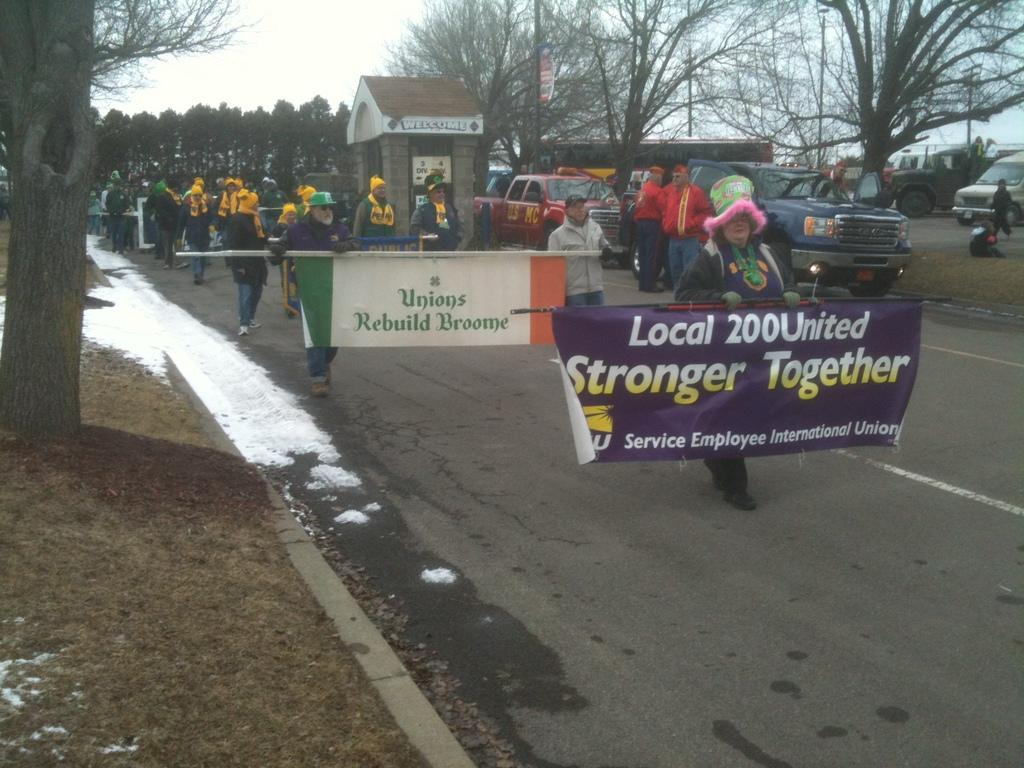<image>
Relay a brief, clear account of the picture shown. A woman leads a parade holding a banner for Local 200 United, Stronger Together. 